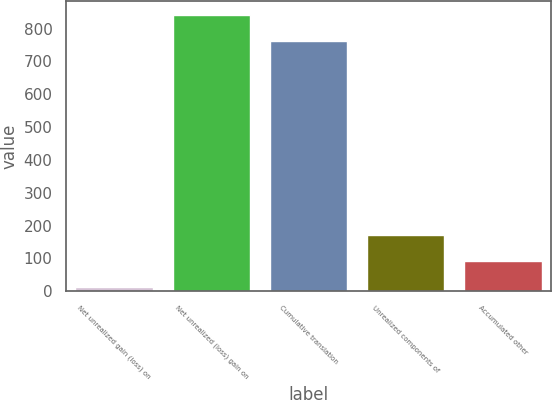<chart> <loc_0><loc_0><loc_500><loc_500><bar_chart><fcel>Net unrealized gain (loss) on<fcel>Net unrealized (loss) gain on<fcel>Cumulative translation<fcel>Unrealized components of<fcel>Accumulated other<nl><fcel>12<fcel>842<fcel>763<fcel>170<fcel>91<nl></chart> 